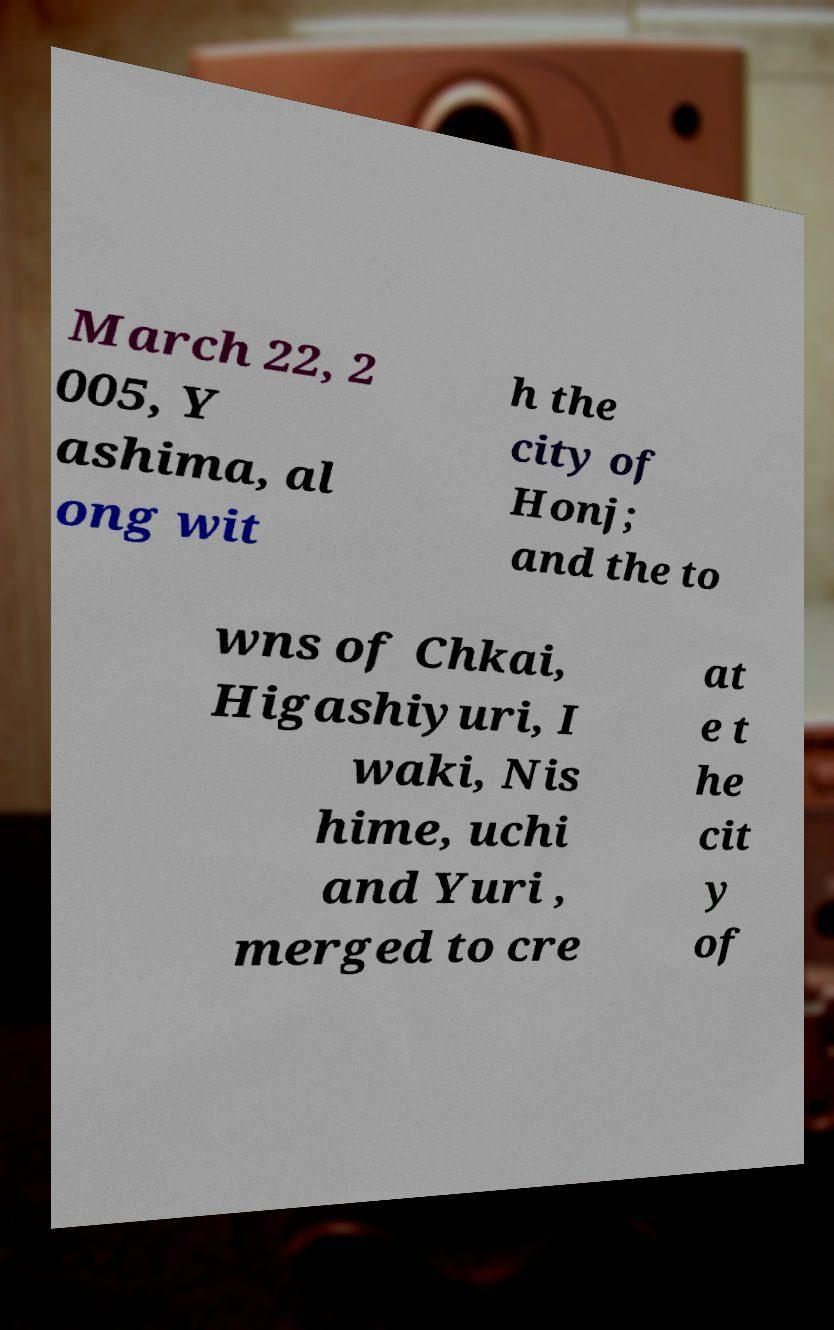Could you assist in decoding the text presented in this image and type it out clearly? March 22, 2 005, Y ashima, al ong wit h the city of Honj; and the to wns of Chkai, Higashiyuri, I waki, Nis hime, uchi and Yuri , merged to cre at e t he cit y of 